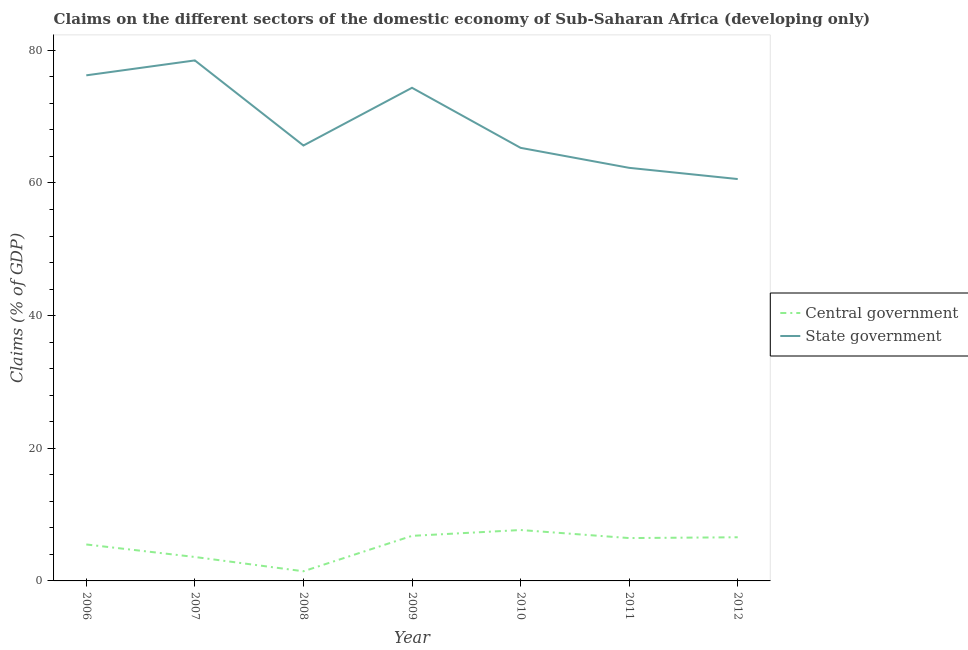What is the claims on state government in 2011?
Offer a very short reply. 62.28. Across all years, what is the maximum claims on central government?
Your answer should be very brief. 7.68. Across all years, what is the minimum claims on state government?
Provide a short and direct response. 60.59. In which year was the claims on central government maximum?
Provide a short and direct response. 2010. What is the total claims on central government in the graph?
Provide a succinct answer. 38.08. What is the difference between the claims on state government in 2009 and that in 2011?
Your answer should be compact. 12.07. What is the difference between the claims on central government in 2009 and the claims on state government in 2010?
Your response must be concise. -58.5. What is the average claims on state government per year?
Provide a short and direct response. 68.99. In the year 2007, what is the difference between the claims on state government and claims on central government?
Give a very brief answer. 74.87. In how many years, is the claims on state government greater than 4 %?
Give a very brief answer. 7. What is the ratio of the claims on state government in 2008 to that in 2012?
Give a very brief answer. 1.08. Is the claims on central government in 2008 less than that in 2009?
Offer a very short reply. Yes. What is the difference between the highest and the second highest claims on central government?
Ensure brevity in your answer.  0.88. What is the difference between the highest and the lowest claims on state government?
Keep it short and to the point. 17.89. Is the claims on state government strictly greater than the claims on central government over the years?
Make the answer very short. Yes. Is the claims on state government strictly less than the claims on central government over the years?
Your response must be concise. No. How many lines are there?
Provide a succinct answer. 2. How many years are there in the graph?
Your answer should be compact. 7. Are the values on the major ticks of Y-axis written in scientific E-notation?
Make the answer very short. No. Where does the legend appear in the graph?
Offer a very short reply. Center right. What is the title of the graph?
Ensure brevity in your answer.  Claims on the different sectors of the domestic economy of Sub-Saharan Africa (developing only). What is the label or title of the Y-axis?
Offer a very short reply. Claims (% of GDP). What is the Claims (% of GDP) in Central government in 2006?
Make the answer very short. 5.5. What is the Claims (% of GDP) in State government in 2006?
Make the answer very short. 76.23. What is the Claims (% of GDP) in Central government in 2007?
Provide a short and direct response. 3.61. What is the Claims (% of GDP) of State government in 2007?
Your answer should be very brief. 78.48. What is the Claims (% of GDP) of Central government in 2008?
Provide a short and direct response. 1.46. What is the Claims (% of GDP) of State government in 2008?
Give a very brief answer. 65.65. What is the Claims (% of GDP) of Central government in 2009?
Ensure brevity in your answer.  6.8. What is the Claims (% of GDP) of State government in 2009?
Your response must be concise. 74.35. What is the Claims (% of GDP) in Central government in 2010?
Offer a very short reply. 7.68. What is the Claims (% of GDP) of State government in 2010?
Your response must be concise. 65.3. What is the Claims (% of GDP) of Central government in 2011?
Your response must be concise. 6.46. What is the Claims (% of GDP) of State government in 2011?
Your answer should be compact. 62.28. What is the Claims (% of GDP) in Central government in 2012?
Provide a succinct answer. 6.58. What is the Claims (% of GDP) in State government in 2012?
Keep it short and to the point. 60.59. Across all years, what is the maximum Claims (% of GDP) of Central government?
Make the answer very short. 7.68. Across all years, what is the maximum Claims (% of GDP) in State government?
Provide a succinct answer. 78.48. Across all years, what is the minimum Claims (% of GDP) in Central government?
Ensure brevity in your answer.  1.46. Across all years, what is the minimum Claims (% of GDP) in State government?
Your response must be concise. 60.59. What is the total Claims (% of GDP) in Central government in the graph?
Your response must be concise. 38.08. What is the total Claims (% of GDP) of State government in the graph?
Ensure brevity in your answer.  482.9. What is the difference between the Claims (% of GDP) of Central government in 2006 and that in 2007?
Provide a succinct answer. 1.89. What is the difference between the Claims (% of GDP) in State government in 2006 and that in 2007?
Provide a short and direct response. -2.25. What is the difference between the Claims (% of GDP) of Central government in 2006 and that in 2008?
Keep it short and to the point. 4.04. What is the difference between the Claims (% of GDP) in State government in 2006 and that in 2008?
Ensure brevity in your answer.  10.58. What is the difference between the Claims (% of GDP) of Central government in 2006 and that in 2009?
Provide a succinct answer. -1.3. What is the difference between the Claims (% of GDP) in State government in 2006 and that in 2009?
Offer a very short reply. 1.88. What is the difference between the Claims (% of GDP) of Central government in 2006 and that in 2010?
Your response must be concise. -2.18. What is the difference between the Claims (% of GDP) of State government in 2006 and that in 2010?
Give a very brief answer. 10.93. What is the difference between the Claims (% of GDP) of Central government in 2006 and that in 2011?
Provide a succinct answer. -0.97. What is the difference between the Claims (% of GDP) of State government in 2006 and that in 2011?
Make the answer very short. 13.95. What is the difference between the Claims (% of GDP) of Central government in 2006 and that in 2012?
Your answer should be compact. -1.09. What is the difference between the Claims (% of GDP) in State government in 2006 and that in 2012?
Offer a very short reply. 15.64. What is the difference between the Claims (% of GDP) in Central government in 2007 and that in 2008?
Offer a terse response. 2.15. What is the difference between the Claims (% of GDP) of State government in 2007 and that in 2008?
Provide a succinct answer. 12.83. What is the difference between the Claims (% of GDP) of Central government in 2007 and that in 2009?
Offer a terse response. -3.19. What is the difference between the Claims (% of GDP) of State government in 2007 and that in 2009?
Your answer should be very brief. 4.13. What is the difference between the Claims (% of GDP) in Central government in 2007 and that in 2010?
Provide a succinct answer. -4.07. What is the difference between the Claims (% of GDP) of State government in 2007 and that in 2010?
Offer a terse response. 13.18. What is the difference between the Claims (% of GDP) in Central government in 2007 and that in 2011?
Your response must be concise. -2.85. What is the difference between the Claims (% of GDP) of State government in 2007 and that in 2011?
Provide a succinct answer. 16.2. What is the difference between the Claims (% of GDP) of Central government in 2007 and that in 2012?
Offer a very short reply. -2.97. What is the difference between the Claims (% of GDP) of State government in 2007 and that in 2012?
Your response must be concise. 17.89. What is the difference between the Claims (% of GDP) of Central government in 2008 and that in 2009?
Your answer should be compact. -5.34. What is the difference between the Claims (% of GDP) in State government in 2008 and that in 2009?
Ensure brevity in your answer.  -8.7. What is the difference between the Claims (% of GDP) of Central government in 2008 and that in 2010?
Offer a very short reply. -6.22. What is the difference between the Claims (% of GDP) of State government in 2008 and that in 2010?
Provide a short and direct response. 0.35. What is the difference between the Claims (% of GDP) in Central government in 2008 and that in 2011?
Your answer should be compact. -5.01. What is the difference between the Claims (% of GDP) of State government in 2008 and that in 2011?
Offer a terse response. 3.37. What is the difference between the Claims (% of GDP) in Central government in 2008 and that in 2012?
Make the answer very short. -5.13. What is the difference between the Claims (% of GDP) of State government in 2008 and that in 2012?
Make the answer very short. 5.06. What is the difference between the Claims (% of GDP) in Central government in 2009 and that in 2010?
Make the answer very short. -0.88. What is the difference between the Claims (% of GDP) of State government in 2009 and that in 2010?
Your answer should be compact. 9.06. What is the difference between the Claims (% of GDP) of Central government in 2009 and that in 2011?
Provide a short and direct response. 0.33. What is the difference between the Claims (% of GDP) in State government in 2009 and that in 2011?
Give a very brief answer. 12.07. What is the difference between the Claims (% of GDP) in Central government in 2009 and that in 2012?
Your answer should be compact. 0.21. What is the difference between the Claims (% of GDP) in State government in 2009 and that in 2012?
Provide a succinct answer. 13.76. What is the difference between the Claims (% of GDP) in Central government in 2010 and that in 2011?
Offer a terse response. 1.21. What is the difference between the Claims (% of GDP) of State government in 2010 and that in 2011?
Make the answer very short. 3.01. What is the difference between the Claims (% of GDP) of Central government in 2010 and that in 2012?
Your response must be concise. 1.09. What is the difference between the Claims (% of GDP) in State government in 2010 and that in 2012?
Your response must be concise. 4.7. What is the difference between the Claims (% of GDP) in Central government in 2011 and that in 2012?
Provide a short and direct response. -0.12. What is the difference between the Claims (% of GDP) of State government in 2011 and that in 2012?
Offer a very short reply. 1.69. What is the difference between the Claims (% of GDP) in Central government in 2006 and the Claims (% of GDP) in State government in 2007?
Offer a terse response. -72.99. What is the difference between the Claims (% of GDP) of Central government in 2006 and the Claims (% of GDP) of State government in 2008?
Offer a very short reply. -60.16. What is the difference between the Claims (% of GDP) of Central government in 2006 and the Claims (% of GDP) of State government in 2009?
Keep it short and to the point. -68.86. What is the difference between the Claims (% of GDP) in Central government in 2006 and the Claims (% of GDP) in State government in 2010?
Provide a short and direct response. -59.8. What is the difference between the Claims (% of GDP) of Central government in 2006 and the Claims (% of GDP) of State government in 2011?
Your response must be concise. -56.79. What is the difference between the Claims (% of GDP) of Central government in 2006 and the Claims (% of GDP) of State government in 2012?
Give a very brief answer. -55.1. What is the difference between the Claims (% of GDP) in Central government in 2007 and the Claims (% of GDP) in State government in 2008?
Give a very brief answer. -62.04. What is the difference between the Claims (% of GDP) of Central government in 2007 and the Claims (% of GDP) of State government in 2009?
Provide a succinct answer. -70.74. What is the difference between the Claims (% of GDP) of Central government in 2007 and the Claims (% of GDP) of State government in 2010?
Keep it short and to the point. -61.69. What is the difference between the Claims (% of GDP) in Central government in 2007 and the Claims (% of GDP) in State government in 2011?
Give a very brief answer. -58.68. What is the difference between the Claims (% of GDP) in Central government in 2007 and the Claims (% of GDP) in State government in 2012?
Your response must be concise. -56.98. What is the difference between the Claims (% of GDP) in Central government in 2008 and the Claims (% of GDP) in State government in 2009?
Provide a succinct answer. -72.9. What is the difference between the Claims (% of GDP) of Central government in 2008 and the Claims (% of GDP) of State government in 2010?
Offer a terse response. -63.84. What is the difference between the Claims (% of GDP) in Central government in 2008 and the Claims (% of GDP) in State government in 2011?
Provide a short and direct response. -60.83. What is the difference between the Claims (% of GDP) in Central government in 2008 and the Claims (% of GDP) in State government in 2012?
Offer a very short reply. -59.14. What is the difference between the Claims (% of GDP) of Central government in 2009 and the Claims (% of GDP) of State government in 2010?
Make the answer very short. -58.5. What is the difference between the Claims (% of GDP) of Central government in 2009 and the Claims (% of GDP) of State government in 2011?
Your answer should be very brief. -55.49. What is the difference between the Claims (% of GDP) of Central government in 2009 and the Claims (% of GDP) of State government in 2012?
Your response must be concise. -53.8. What is the difference between the Claims (% of GDP) of Central government in 2010 and the Claims (% of GDP) of State government in 2011?
Give a very brief answer. -54.61. What is the difference between the Claims (% of GDP) in Central government in 2010 and the Claims (% of GDP) in State government in 2012?
Your response must be concise. -52.92. What is the difference between the Claims (% of GDP) in Central government in 2011 and the Claims (% of GDP) in State government in 2012?
Provide a short and direct response. -54.13. What is the average Claims (% of GDP) in Central government per year?
Give a very brief answer. 5.44. What is the average Claims (% of GDP) in State government per year?
Offer a very short reply. 68.99. In the year 2006, what is the difference between the Claims (% of GDP) of Central government and Claims (% of GDP) of State government?
Provide a short and direct response. -70.74. In the year 2007, what is the difference between the Claims (% of GDP) of Central government and Claims (% of GDP) of State government?
Offer a very short reply. -74.87. In the year 2008, what is the difference between the Claims (% of GDP) of Central government and Claims (% of GDP) of State government?
Offer a very short reply. -64.2. In the year 2009, what is the difference between the Claims (% of GDP) of Central government and Claims (% of GDP) of State government?
Ensure brevity in your answer.  -67.56. In the year 2010, what is the difference between the Claims (% of GDP) in Central government and Claims (% of GDP) in State government?
Provide a succinct answer. -57.62. In the year 2011, what is the difference between the Claims (% of GDP) of Central government and Claims (% of GDP) of State government?
Your response must be concise. -55.82. In the year 2012, what is the difference between the Claims (% of GDP) of Central government and Claims (% of GDP) of State government?
Offer a very short reply. -54.01. What is the ratio of the Claims (% of GDP) in Central government in 2006 to that in 2007?
Give a very brief answer. 1.52. What is the ratio of the Claims (% of GDP) in State government in 2006 to that in 2007?
Ensure brevity in your answer.  0.97. What is the ratio of the Claims (% of GDP) of Central government in 2006 to that in 2008?
Ensure brevity in your answer.  3.78. What is the ratio of the Claims (% of GDP) of State government in 2006 to that in 2008?
Offer a terse response. 1.16. What is the ratio of the Claims (% of GDP) of Central government in 2006 to that in 2009?
Keep it short and to the point. 0.81. What is the ratio of the Claims (% of GDP) in State government in 2006 to that in 2009?
Offer a very short reply. 1.03. What is the ratio of the Claims (% of GDP) in Central government in 2006 to that in 2010?
Your response must be concise. 0.72. What is the ratio of the Claims (% of GDP) in State government in 2006 to that in 2010?
Offer a very short reply. 1.17. What is the ratio of the Claims (% of GDP) in Central government in 2006 to that in 2011?
Keep it short and to the point. 0.85. What is the ratio of the Claims (% of GDP) in State government in 2006 to that in 2011?
Keep it short and to the point. 1.22. What is the ratio of the Claims (% of GDP) of Central government in 2006 to that in 2012?
Give a very brief answer. 0.83. What is the ratio of the Claims (% of GDP) in State government in 2006 to that in 2012?
Your answer should be compact. 1.26. What is the ratio of the Claims (% of GDP) of Central government in 2007 to that in 2008?
Provide a short and direct response. 2.48. What is the ratio of the Claims (% of GDP) of State government in 2007 to that in 2008?
Provide a succinct answer. 1.2. What is the ratio of the Claims (% of GDP) in Central government in 2007 to that in 2009?
Your response must be concise. 0.53. What is the ratio of the Claims (% of GDP) in State government in 2007 to that in 2009?
Your answer should be compact. 1.06. What is the ratio of the Claims (% of GDP) in Central government in 2007 to that in 2010?
Make the answer very short. 0.47. What is the ratio of the Claims (% of GDP) in State government in 2007 to that in 2010?
Your response must be concise. 1.2. What is the ratio of the Claims (% of GDP) in Central government in 2007 to that in 2011?
Your answer should be very brief. 0.56. What is the ratio of the Claims (% of GDP) in State government in 2007 to that in 2011?
Ensure brevity in your answer.  1.26. What is the ratio of the Claims (% of GDP) of Central government in 2007 to that in 2012?
Keep it short and to the point. 0.55. What is the ratio of the Claims (% of GDP) in State government in 2007 to that in 2012?
Give a very brief answer. 1.3. What is the ratio of the Claims (% of GDP) in Central government in 2008 to that in 2009?
Offer a very short reply. 0.21. What is the ratio of the Claims (% of GDP) in State government in 2008 to that in 2009?
Make the answer very short. 0.88. What is the ratio of the Claims (% of GDP) of Central government in 2008 to that in 2010?
Make the answer very short. 0.19. What is the ratio of the Claims (% of GDP) in State government in 2008 to that in 2010?
Your answer should be very brief. 1.01. What is the ratio of the Claims (% of GDP) of Central government in 2008 to that in 2011?
Keep it short and to the point. 0.23. What is the ratio of the Claims (% of GDP) of State government in 2008 to that in 2011?
Your answer should be very brief. 1.05. What is the ratio of the Claims (% of GDP) in Central government in 2008 to that in 2012?
Provide a short and direct response. 0.22. What is the ratio of the Claims (% of GDP) in State government in 2008 to that in 2012?
Offer a very short reply. 1.08. What is the ratio of the Claims (% of GDP) in Central government in 2009 to that in 2010?
Keep it short and to the point. 0.89. What is the ratio of the Claims (% of GDP) of State government in 2009 to that in 2010?
Your answer should be very brief. 1.14. What is the ratio of the Claims (% of GDP) in Central government in 2009 to that in 2011?
Provide a succinct answer. 1.05. What is the ratio of the Claims (% of GDP) of State government in 2009 to that in 2011?
Your answer should be compact. 1.19. What is the ratio of the Claims (% of GDP) of Central government in 2009 to that in 2012?
Offer a terse response. 1.03. What is the ratio of the Claims (% of GDP) in State government in 2009 to that in 2012?
Your answer should be compact. 1.23. What is the ratio of the Claims (% of GDP) of Central government in 2010 to that in 2011?
Offer a very short reply. 1.19. What is the ratio of the Claims (% of GDP) of State government in 2010 to that in 2011?
Keep it short and to the point. 1.05. What is the ratio of the Claims (% of GDP) of Central government in 2010 to that in 2012?
Your answer should be very brief. 1.17. What is the ratio of the Claims (% of GDP) in State government in 2010 to that in 2012?
Offer a terse response. 1.08. What is the ratio of the Claims (% of GDP) in Central government in 2011 to that in 2012?
Ensure brevity in your answer.  0.98. What is the ratio of the Claims (% of GDP) in State government in 2011 to that in 2012?
Your response must be concise. 1.03. What is the difference between the highest and the second highest Claims (% of GDP) of Central government?
Keep it short and to the point. 0.88. What is the difference between the highest and the second highest Claims (% of GDP) of State government?
Offer a very short reply. 2.25. What is the difference between the highest and the lowest Claims (% of GDP) of Central government?
Provide a succinct answer. 6.22. What is the difference between the highest and the lowest Claims (% of GDP) of State government?
Your answer should be very brief. 17.89. 